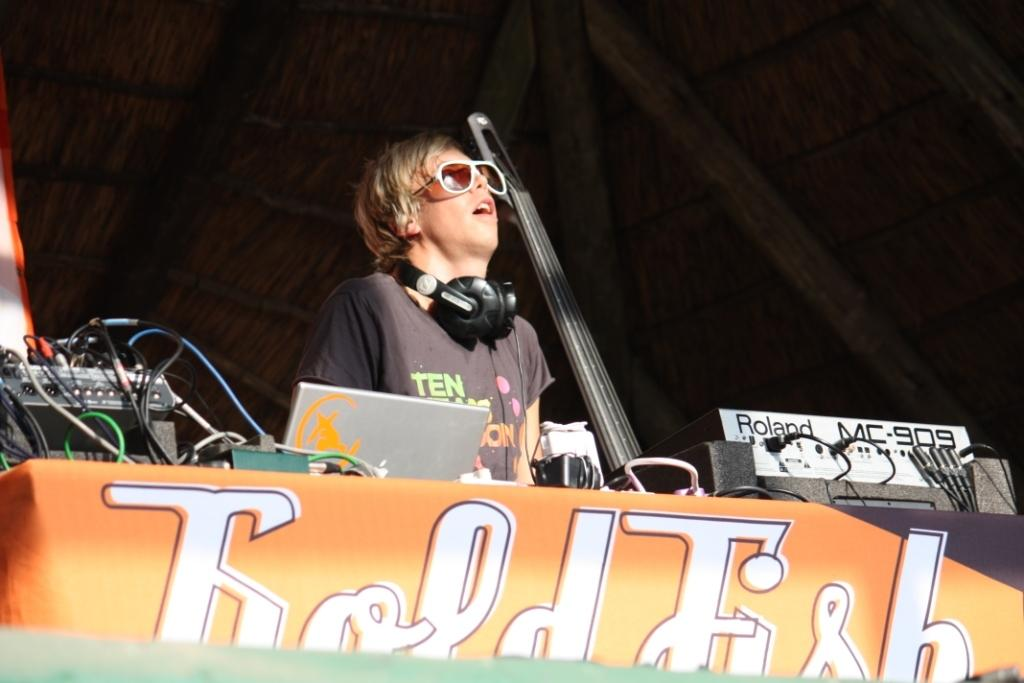What is the main subject of the image? There is a person in the image. What can be seen on the table in the image? There are electronic gadgets on a table in the image. How would you describe the lighting in the image? The background of the image is dark. How many mice are visible on the person's feet in the image? There are no mice visible on the person's feet in the image. Can you describe the action of the person turning on the electronic gadgets in the image? There is no indication of the person turning on the electronic gadgets in the image. 